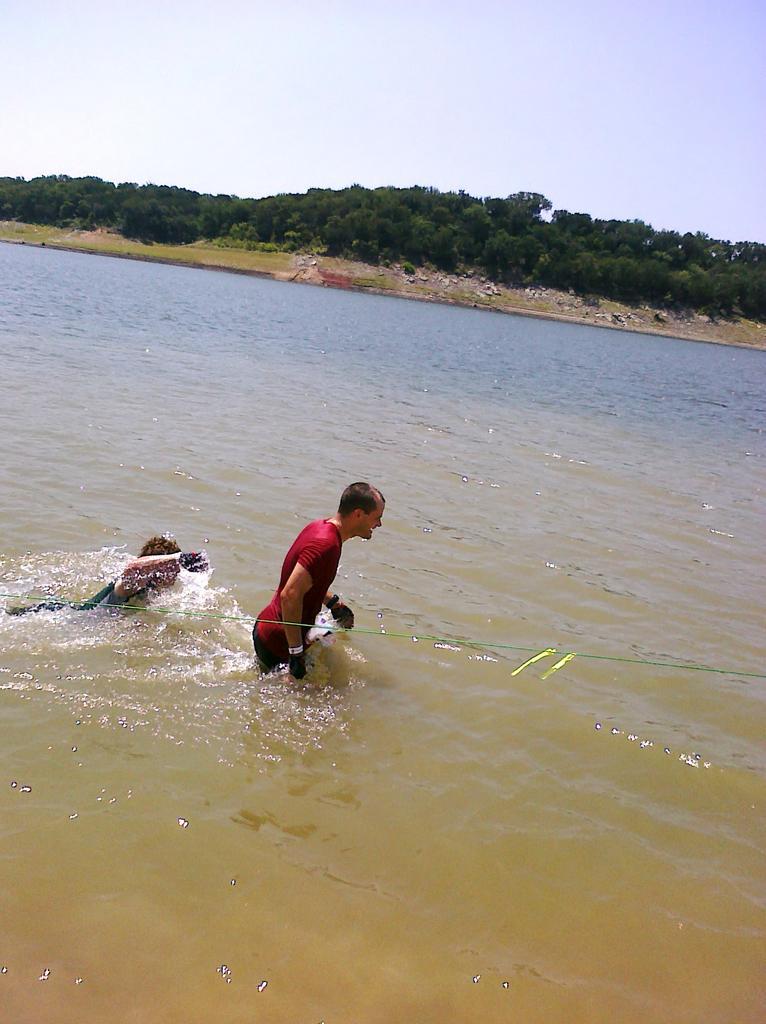Describe this image in one or two sentences. In this image there is a man in the water. Behind him there is another person who is swimming in the water. In the background there are trees. At the top there is sky. Beside the trees there is a ground on which there are stones and grass. 